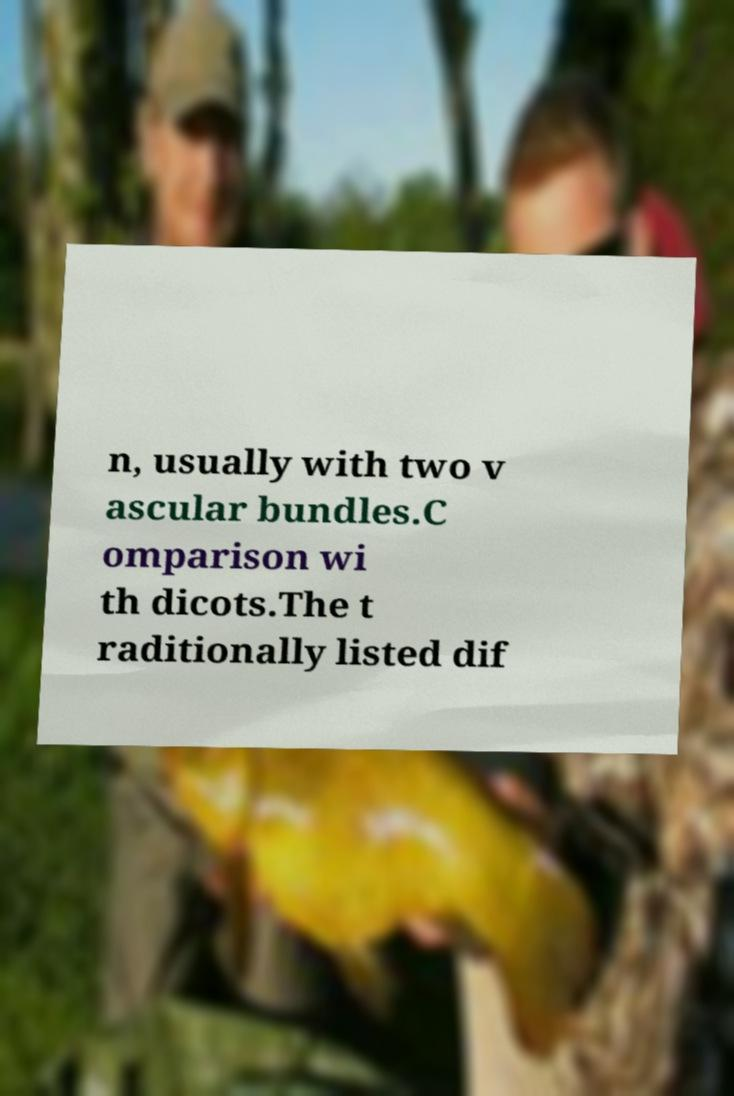Could you extract and type out the text from this image? n, usually with two v ascular bundles.C omparison wi th dicots.The t raditionally listed dif 